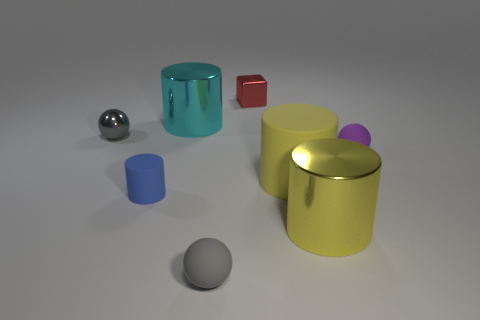Subtract all yellow cylinders. How many gray balls are left? 2 Subtract all gray balls. How many balls are left? 1 Add 1 cylinders. How many objects exist? 9 Subtract 2 cylinders. How many cylinders are left? 2 Subtract all cyan cylinders. How many cylinders are left? 3 Subtract all balls. How many objects are left? 5 Subtract all metallic objects. Subtract all blue things. How many objects are left? 3 Add 4 tiny blue cylinders. How many tiny blue cylinders are left? 5 Add 2 blue rubber cylinders. How many blue rubber cylinders exist? 3 Subtract 2 yellow cylinders. How many objects are left? 6 